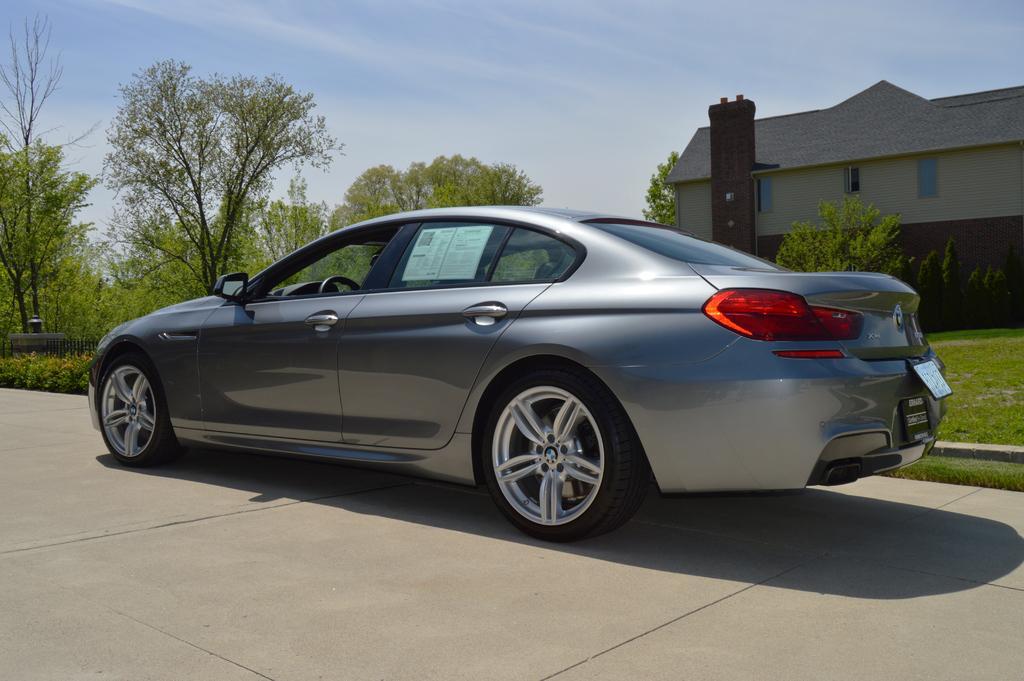Describe this image in one or two sentences. In this image in front there is a car on the road. Behind the car there's grass on the surface. In the background of the image there are trees, building and sky. 